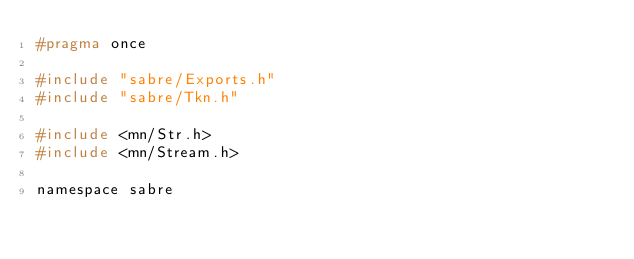Convert code to text. <code><loc_0><loc_0><loc_500><loc_500><_C_>#pragma once

#include "sabre/Exports.h"
#include "sabre/Tkn.h"

#include <mn/Str.h>
#include <mn/Stream.h>

namespace sabre</code> 